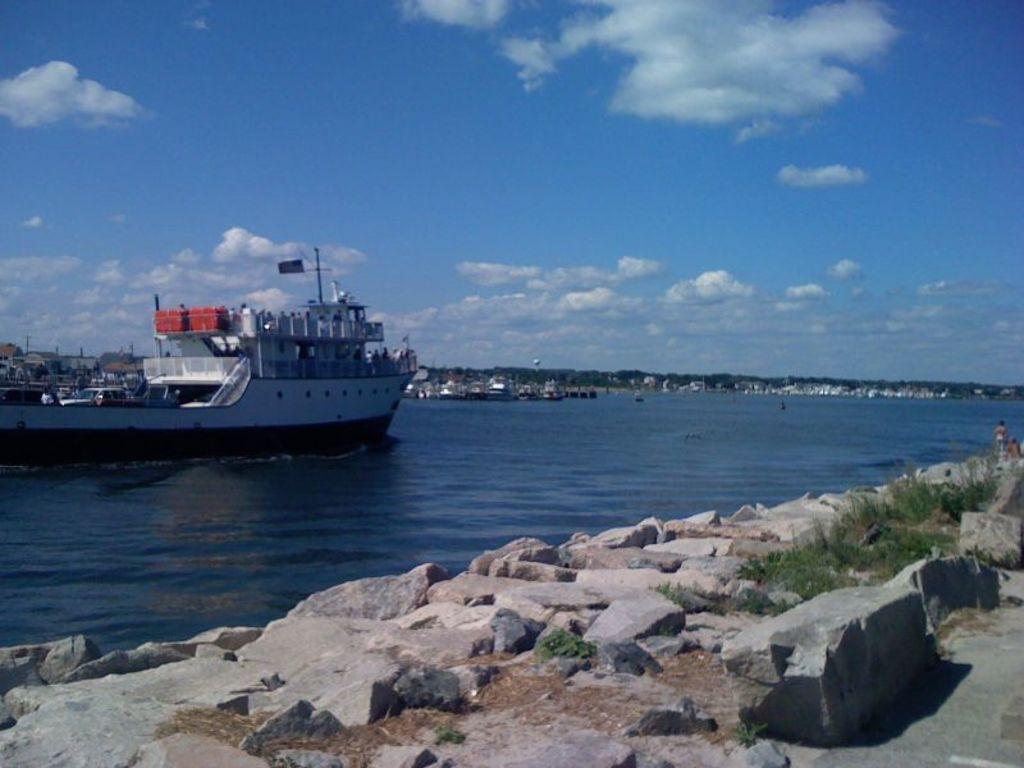How would you summarize this image in a sentence or two? In the foreground of this image, there are rocks side to the road. In the background, there is a ship on the water, greenery, buildings, sky and the cloud. 